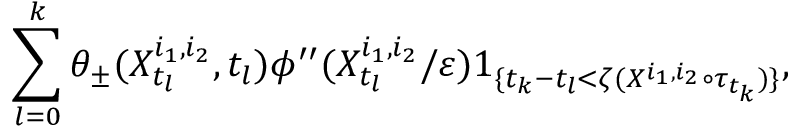Convert formula to latex. <formula><loc_0><loc_0><loc_500><loc_500>\sum _ { l = 0 } ^ { k } \theta _ { \pm } ( X _ { t _ { l } } ^ { i _ { 1 } , i _ { 2 } } , t _ { l } ) \phi ^ { \prime \prime } ( X _ { t _ { l } } ^ { i _ { 1 } , i _ { 2 } } / \varepsilon ) 1 _ { \{ t _ { k } - t _ { l } < \zeta ( X ^ { i _ { 1 } , i _ { 2 } } \circ \tau _ { t _ { k } } ) \} } ,</formula> 